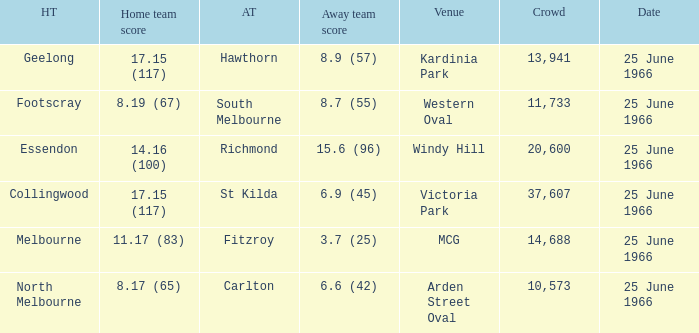Where did the away team score 8.7 (55)? Western Oval. Write the full table. {'header': ['HT', 'Home team score', 'AT', 'Away team score', 'Venue', 'Crowd', 'Date'], 'rows': [['Geelong', '17.15 (117)', 'Hawthorn', '8.9 (57)', 'Kardinia Park', '13,941', '25 June 1966'], ['Footscray', '8.19 (67)', 'South Melbourne', '8.7 (55)', 'Western Oval', '11,733', '25 June 1966'], ['Essendon', '14.16 (100)', 'Richmond', '15.6 (96)', 'Windy Hill', '20,600', '25 June 1966'], ['Collingwood', '17.15 (117)', 'St Kilda', '6.9 (45)', 'Victoria Park', '37,607', '25 June 1966'], ['Melbourne', '11.17 (83)', 'Fitzroy', '3.7 (25)', 'MCG', '14,688', '25 June 1966'], ['North Melbourne', '8.17 (65)', 'Carlton', '6.6 (42)', 'Arden Street Oval', '10,573', '25 June 1966']]} 